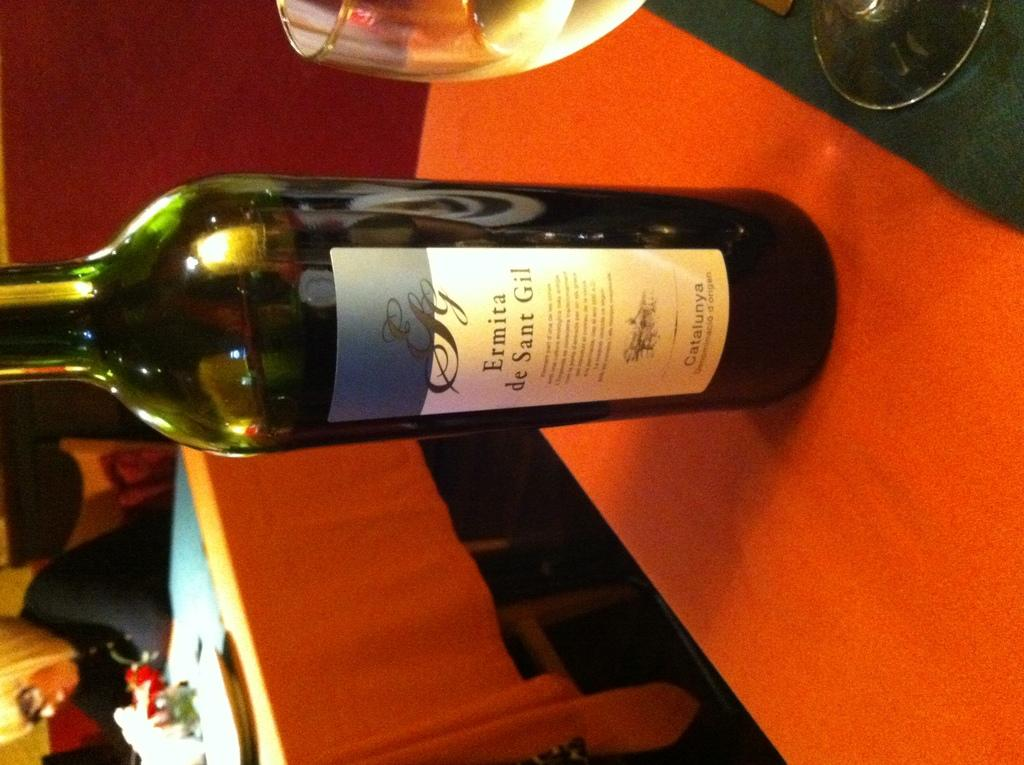Provide a one-sentence caption for the provided image. Bottle of  Ermita de sant gil wine in a green bottle. 